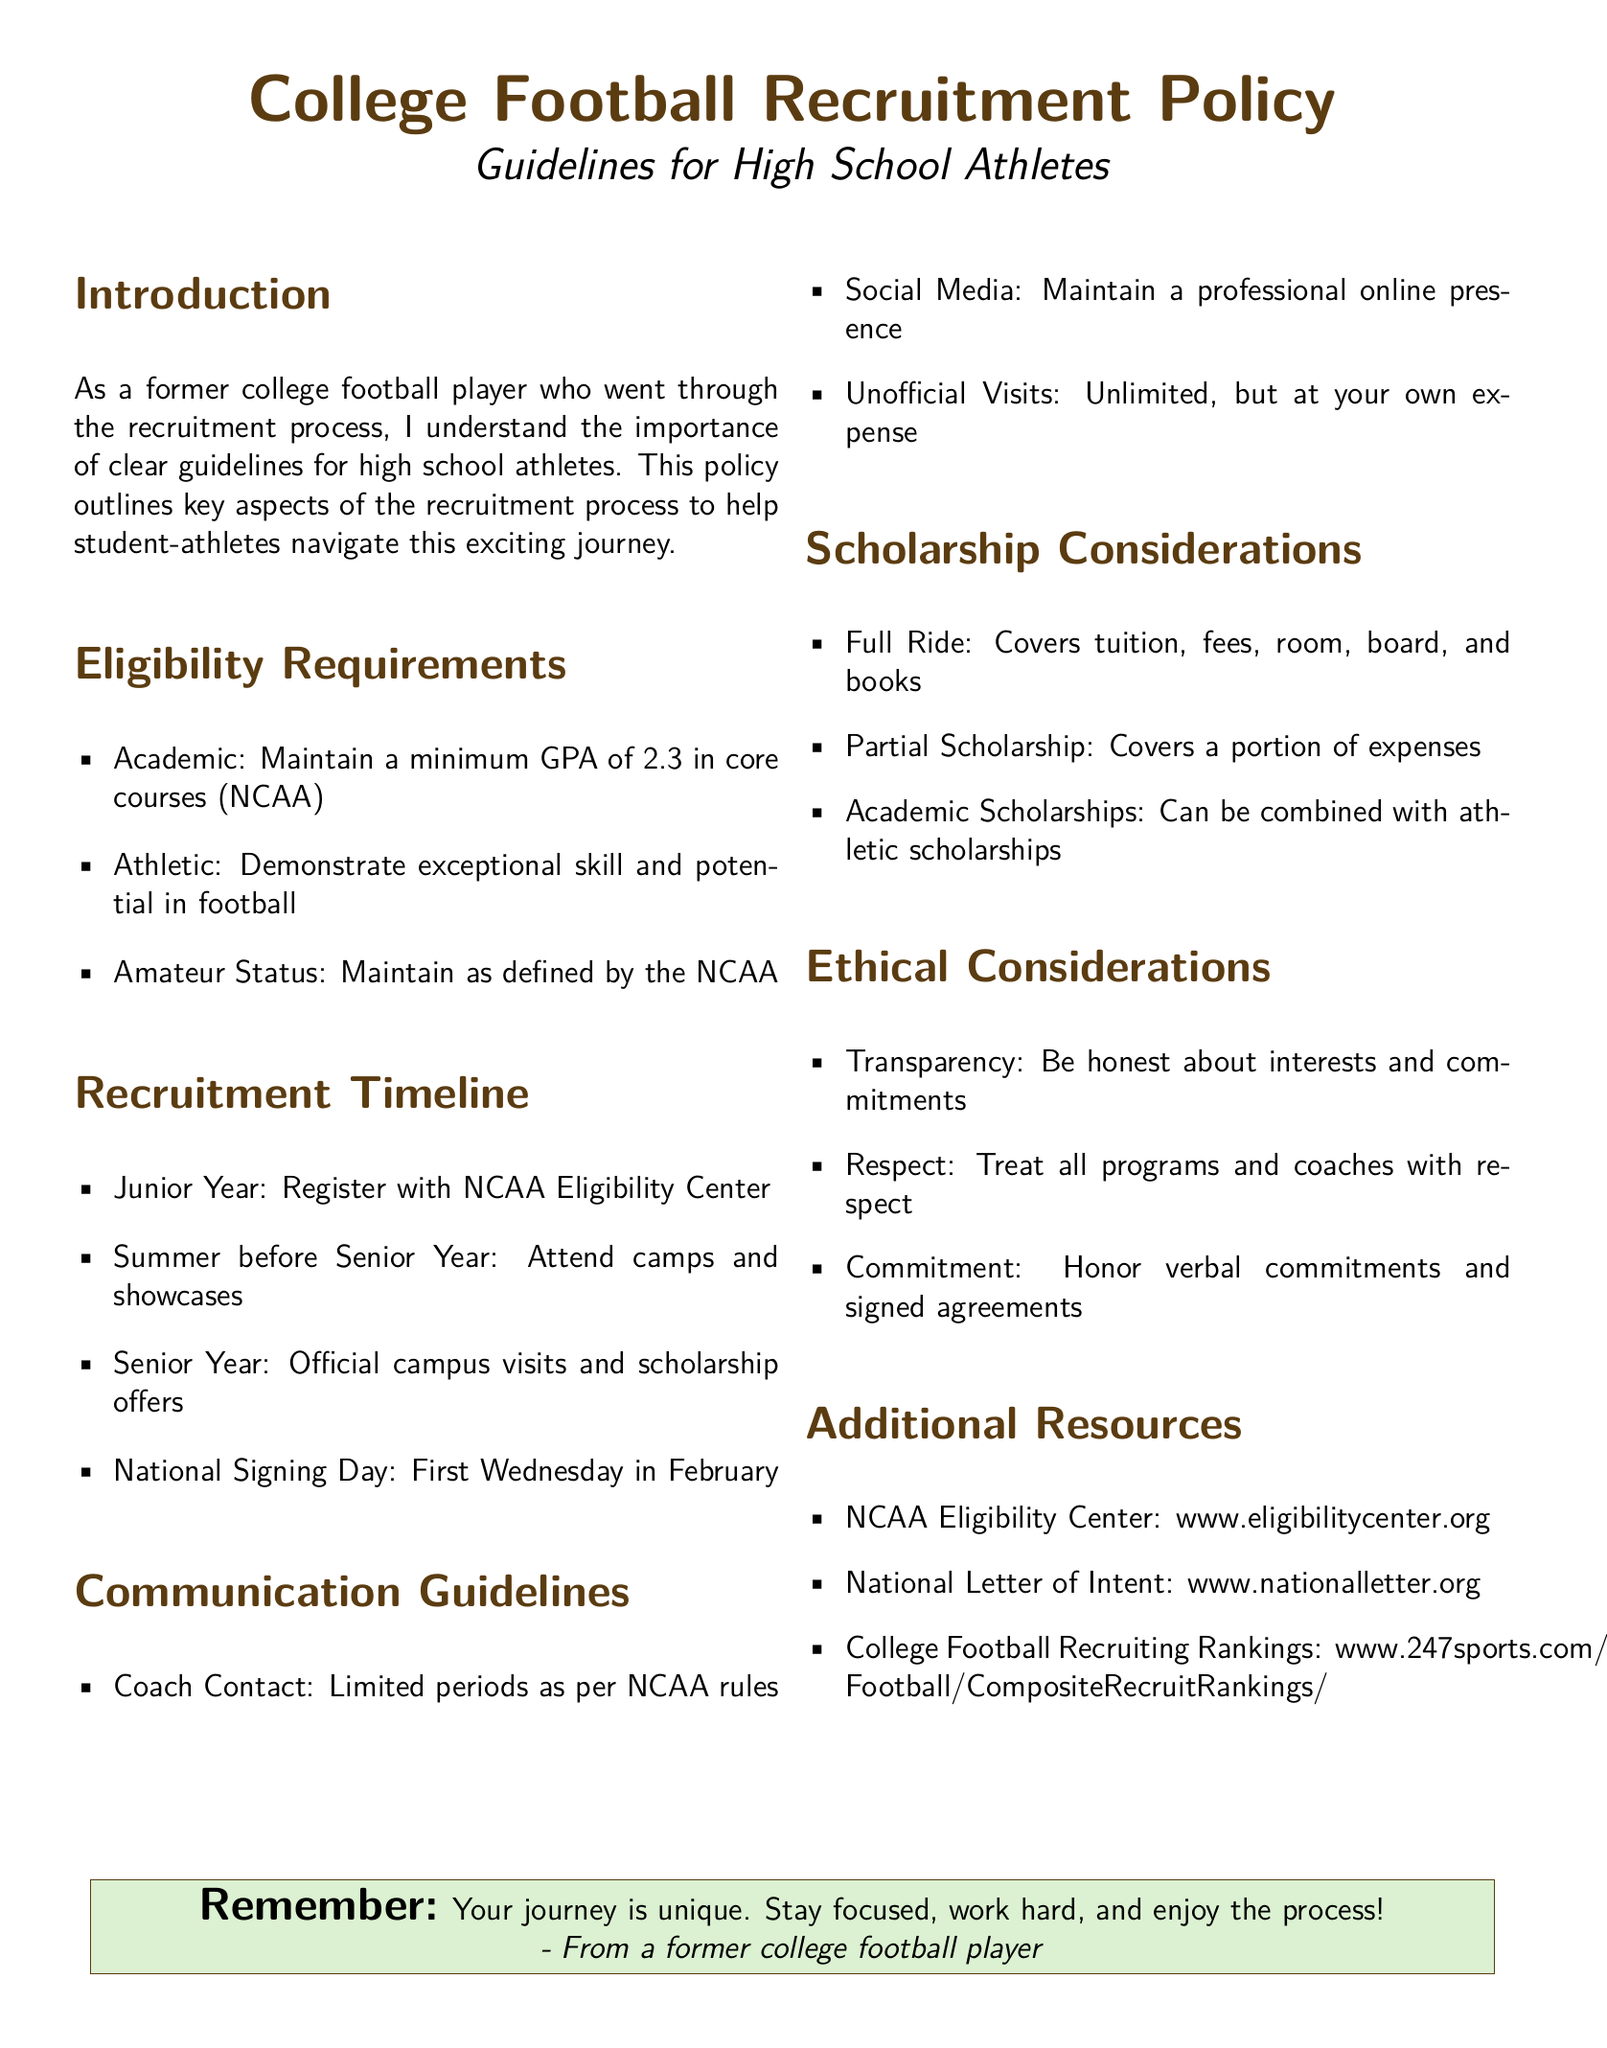What is the minimum GPA required? The document states that a minimum GPA of 2.3 in core courses is required as per NCAA.
Answer: 2.3 What year should athletes register with the NCAA Eligibility Center? According to the recruitment timeline, athletes should register in their junior year.
Answer: Junior Year What type of scholarship covers all expenses? The document specifies that a full ride covers tuition, fees, room, board, and books.
Answer: Full Ride How should athletes maintain their online presence? The communication guidelines advise that athletes should maintain a professional online presence.
Answer: Professional What is the first Wednesday in February known as? The document mentions this date as National Signing Day.
Answer: National Signing Day What is expected of athletes regarding verbal commitments? The ethical considerations section states that athletes should honor verbal commitments and signed agreements.
Answer: Honor What is an example of a scholarship that can be combined with athletic scholarships? The document states that academic scholarships can be combined with athletic scholarships.
Answer: Academic Scholarships How many unofficial visits can a recruit have? Unofficial visits are stated to be unlimited, but at the athlete's own expense.
Answer: Unlimited 